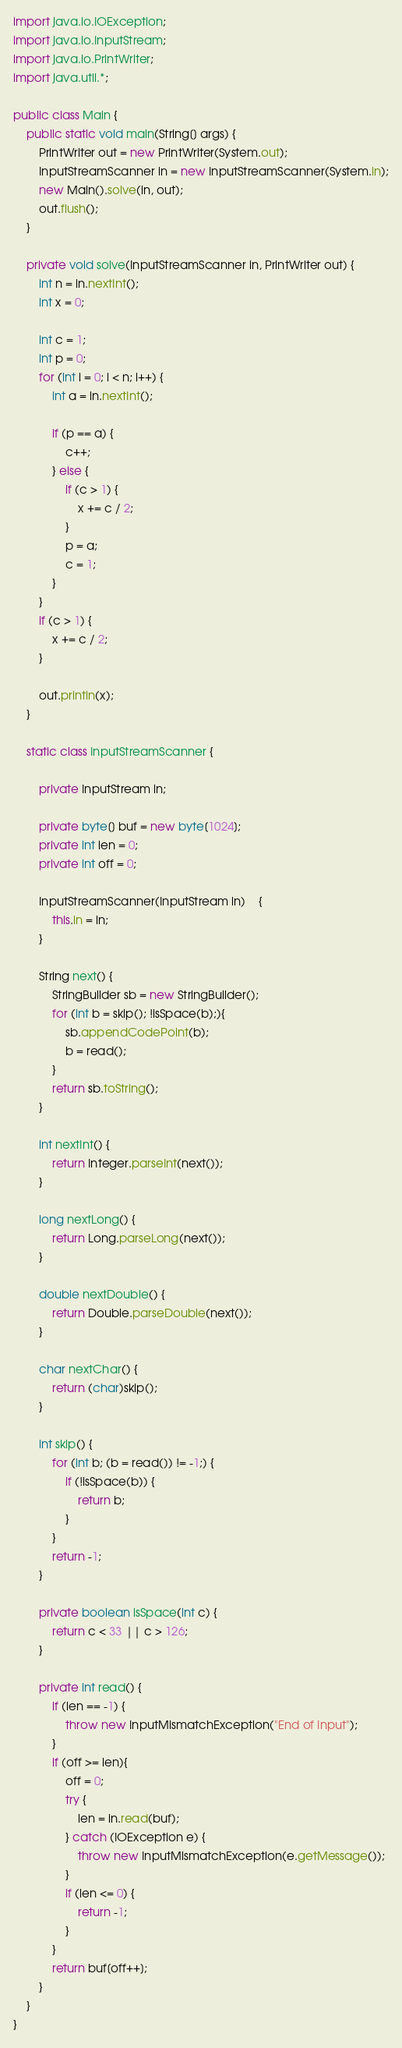Convert code to text. <code><loc_0><loc_0><loc_500><loc_500><_Java_>import java.io.IOException;
import java.io.InputStream;
import java.io.PrintWriter;
import java.util.*;

public class Main {
    public static void main(String[] args) {
        PrintWriter out = new PrintWriter(System.out);
        InputStreamScanner in = new InputStreamScanner(System.in);
        new Main().solve(in, out);
        out.flush();
    }

    private void solve(InputStreamScanner in, PrintWriter out) {
        int n = in.nextInt();
        int x = 0;

        int c = 1;
        int p = 0;
        for (int i = 0; i < n; i++) {
            int a = in.nextInt();

            if (p == a) {
                c++;
            } else {
                if (c > 1) {
                    x += c / 2;
                }
                p = a;
                c = 1;
            }
        }
        if (c > 1) {
            x += c / 2;
        }

        out.println(x);
    }

    static class InputStreamScanner {

        private InputStream in;

        private byte[] buf = new byte[1024];
        private int len = 0;
        private int off = 0;

        InputStreamScanner(InputStream in)	{
            this.in = in;
        }

        String next() {
            StringBuilder sb = new StringBuilder();
            for (int b = skip(); !isSpace(b);){
                sb.appendCodePoint(b);
                b = read();
            }
            return sb.toString();
        }

        int nextInt() {
            return Integer.parseInt(next());
        }

        long nextLong() {
            return Long.parseLong(next());
        }

        double nextDouble() {
            return Double.parseDouble(next());
        }

        char nextChar() {
            return (char)skip();
        }

        int skip() {
            for (int b; (b = read()) != -1;) {
                if (!isSpace(b)) {
                    return b;
                }
            }
            return -1;
        }

        private boolean isSpace(int c) {
            return c < 33 || c > 126;
        }

        private int read() {
            if (len == -1) {
                throw new InputMismatchException("End of Input");
            }
            if (off >= len){
                off = 0;
                try {
                    len = in.read(buf);
                } catch (IOException e) {
                    throw new InputMismatchException(e.getMessage());
                }
                if (len <= 0) {
                    return -1;
                }
            }
            return buf[off++];
        }
    }
}</code> 